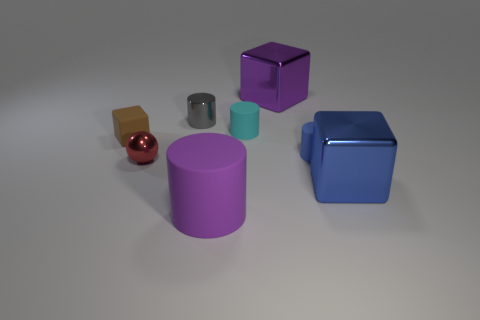The object that is the same color as the large cylinder is what shape?
Provide a short and direct response. Cube. Are there an equal number of cyan rubber cylinders on the left side of the tiny cyan cylinder and purple things?
Your response must be concise. No. What number of cylinders are tiny cyan matte objects or gray metallic objects?
Offer a terse response. 2. What color is the small cylinder that is the same material as the red ball?
Your answer should be very brief. Gray. Is the material of the big purple cylinder the same as the block on the left side of the gray object?
Give a very brief answer. Yes. How many things are either cyan rubber objects or big yellow matte balls?
Offer a very short reply. 1. There is a block that is the same color as the large matte object; what is its material?
Give a very brief answer. Metal. Are there any tiny cyan things that have the same shape as the large rubber object?
Provide a succinct answer. Yes. How many metallic things are in front of the gray metallic object?
Your answer should be compact. 2. What is the large purple thing in front of the gray thing behind the tiny blue cylinder made of?
Give a very brief answer. Rubber. 